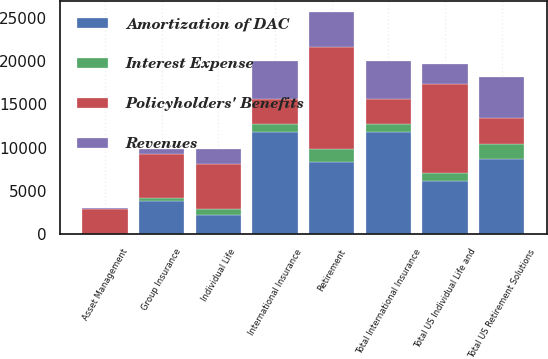Convert chart to OTSL. <chart><loc_0><loc_0><loc_500><loc_500><stacked_bar_chart><ecel><fcel>Retirement<fcel>Asset Management<fcel>Total US Retirement Solutions<fcel>Individual Life<fcel>Group Insurance<fcel>Total US Individual Life and<fcel>International Insurance<fcel>Total International Insurance<nl><fcel>Policyholders' Benefits<fcel>11821<fcel>2944<fcel>2944<fcel>5233<fcel>5143<fcel>10376<fcel>2944<fcel>2944<nl><fcel>Revenues<fcel>4082<fcel>111<fcel>4796<fcel>1669<fcel>586<fcel>2255<fcel>4357<fcel>4357<nl><fcel>Amortization of DAC<fcel>8352<fcel>0<fcel>8666<fcel>2245<fcel>3868<fcel>6113<fcel>11821<fcel>11821<nl><fcel>Interest Expense<fcel>1441<fcel>0<fcel>1804<fcel>644<fcel>257<fcel>901<fcel>880<fcel>880<nl></chart> 